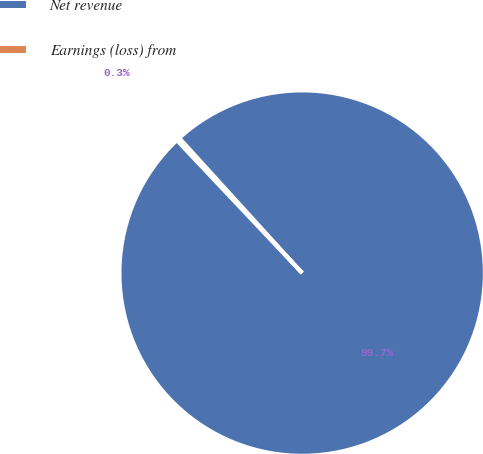Convert chart. <chart><loc_0><loc_0><loc_500><loc_500><pie_chart><fcel>Net revenue<fcel>Earnings (loss) from<nl><fcel>99.71%<fcel>0.29%<nl></chart> 